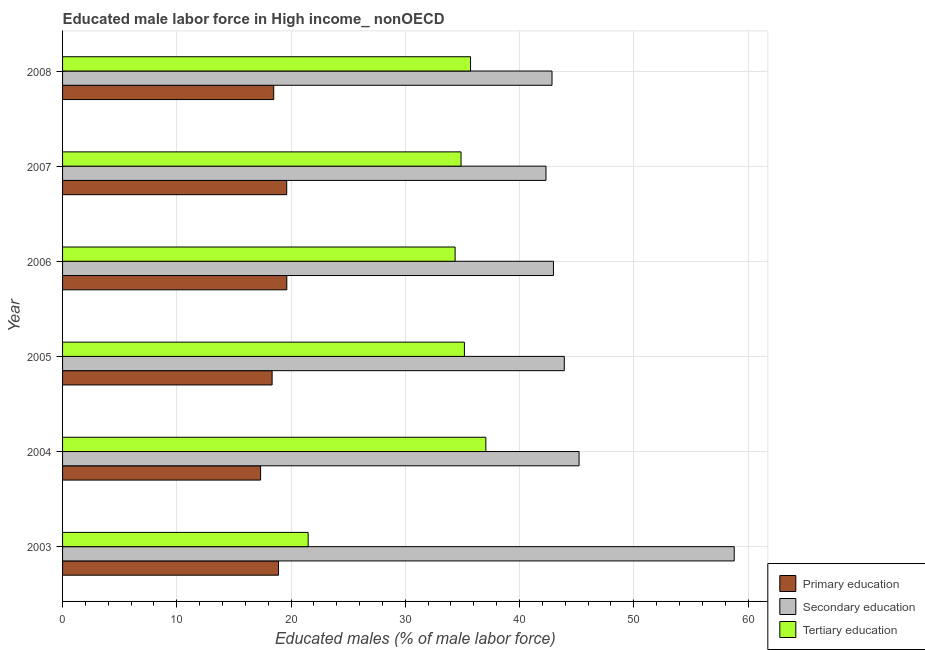How many different coloured bars are there?
Give a very brief answer. 3. How many groups of bars are there?
Make the answer very short. 6. Are the number of bars per tick equal to the number of legend labels?
Your response must be concise. Yes. Are the number of bars on each tick of the Y-axis equal?
Provide a short and direct response. Yes. How many bars are there on the 2nd tick from the top?
Your answer should be very brief. 3. How many bars are there on the 1st tick from the bottom?
Offer a terse response. 3. What is the percentage of male labor force who received secondary education in 2005?
Ensure brevity in your answer.  43.92. Across all years, what is the maximum percentage of male labor force who received tertiary education?
Your answer should be very brief. 37.05. Across all years, what is the minimum percentage of male labor force who received primary education?
Ensure brevity in your answer.  17.34. What is the total percentage of male labor force who received tertiary education in the graph?
Your response must be concise. 198.68. What is the difference between the percentage of male labor force who received tertiary education in 2004 and that in 2008?
Your answer should be compact. 1.34. What is the difference between the percentage of male labor force who received tertiary education in 2003 and the percentage of male labor force who received primary education in 2005?
Your answer should be compact. 3.16. What is the average percentage of male labor force who received secondary education per year?
Keep it short and to the point. 46.01. In the year 2005, what is the difference between the percentage of male labor force who received secondary education and percentage of male labor force who received primary education?
Provide a short and direct response. 25.58. In how many years, is the percentage of male labor force who received primary education greater than 24 %?
Keep it short and to the point. 0. What is the ratio of the percentage of male labor force who received primary education in 2005 to that in 2006?
Your answer should be very brief. 0.93. Is the percentage of male labor force who received tertiary education in 2003 less than that in 2004?
Your response must be concise. Yes. Is the difference between the percentage of male labor force who received tertiary education in 2004 and 2006 greater than the difference between the percentage of male labor force who received primary education in 2004 and 2006?
Provide a succinct answer. Yes. What is the difference between the highest and the second highest percentage of male labor force who received tertiary education?
Your response must be concise. 1.34. In how many years, is the percentage of male labor force who received secondary education greater than the average percentage of male labor force who received secondary education taken over all years?
Your response must be concise. 1. What does the 2nd bar from the top in 2006 represents?
Your response must be concise. Secondary education. What does the 3rd bar from the bottom in 2006 represents?
Make the answer very short. Tertiary education. How many bars are there?
Offer a very short reply. 18. Are all the bars in the graph horizontal?
Your answer should be very brief. Yes. How many years are there in the graph?
Ensure brevity in your answer.  6. Does the graph contain any zero values?
Provide a succinct answer. No. Where does the legend appear in the graph?
Your answer should be very brief. Bottom right. How are the legend labels stacked?
Your answer should be compact. Vertical. What is the title of the graph?
Provide a short and direct response. Educated male labor force in High income_ nonOECD. Does "Agriculture" appear as one of the legend labels in the graph?
Ensure brevity in your answer.  No. What is the label or title of the X-axis?
Offer a very short reply. Educated males (% of male labor force). What is the label or title of the Y-axis?
Your answer should be compact. Year. What is the Educated males (% of male labor force) of Primary education in 2003?
Keep it short and to the point. 18.9. What is the Educated males (% of male labor force) of Secondary education in 2003?
Ensure brevity in your answer.  58.79. What is the Educated males (% of male labor force) in Tertiary education in 2003?
Your answer should be very brief. 21.5. What is the Educated males (% of male labor force) in Primary education in 2004?
Your response must be concise. 17.34. What is the Educated males (% of male labor force) in Secondary education in 2004?
Keep it short and to the point. 45.21. What is the Educated males (% of male labor force) of Tertiary education in 2004?
Provide a short and direct response. 37.05. What is the Educated males (% of male labor force) of Primary education in 2005?
Your response must be concise. 18.34. What is the Educated males (% of male labor force) in Secondary education in 2005?
Give a very brief answer. 43.92. What is the Educated males (% of male labor force) of Tertiary education in 2005?
Keep it short and to the point. 35.18. What is the Educated males (% of male labor force) in Primary education in 2006?
Give a very brief answer. 19.63. What is the Educated males (% of male labor force) in Secondary education in 2006?
Make the answer very short. 42.97. What is the Educated males (% of male labor force) of Tertiary education in 2006?
Keep it short and to the point. 34.36. What is the Educated males (% of male labor force) in Primary education in 2007?
Keep it short and to the point. 19.62. What is the Educated males (% of male labor force) in Secondary education in 2007?
Give a very brief answer. 42.32. What is the Educated males (% of male labor force) in Tertiary education in 2007?
Your answer should be very brief. 34.88. What is the Educated males (% of male labor force) in Primary education in 2008?
Provide a succinct answer. 18.48. What is the Educated males (% of male labor force) of Secondary education in 2008?
Give a very brief answer. 42.84. What is the Educated males (% of male labor force) of Tertiary education in 2008?
Give a very brief answer. 35.71. Across all years, what is the maximum Educated males (% of male labor force) in Primary education?
Make the answer very short. 19.63. Across all years, what is the maximum Educated males (% of male labor force) of Secondary education?
Provide a short and direct response. 58.79. Across all years, what is the maximum Educated males (% of male labor force) in Tertiary education?
Provide a short and direct response. 37.05. Across all years, what is the minimum Educated males (% of male labor force) in Primary education?
Offer a terse response. 17.34. Across all years, what is the minimum Educated males (% of male labor force) of Secondary education?
Your answer should be very brief. 42.32. Across all years, what is the minimum Educated males (% of male labor force) in Tertiary education?
Offer a terse response. 21.5. What is the total Educated males (% of male labor force) of Primary education in the graph?
Offer a very short reply. 112.32. What is the total Educated males (% of male labor force) of Secondary education in the graph?
Provide a succinct answer. 276.06. What is the total Educated males (% of male labor force) of Tertiary education in the graph?
Your answer should be very brief. 198.68. What is the difference between the Educated males (% of male labor force) of Primary education in 2003 and that in 2004?
Offer a very short reply. 1.57. What is the difference between the Educated males (% of male labor force) in Secondary education in 2003 and that in 2004?
Provide a short and direct response. 13.58. What is the difference between the Educated males (% of male labor force) of Tertiary education in 2003 and that in 2004?
Your answer should be very brief. -15.55. What is the difference between the Educated males (% of male labor force) in Primary education in 2003 and that in 2005?
Your answer should be compact. 0.56. What is the difference between the Educated males (% of male labor force) of Secondary education in 2003 and that in 2005?
Your response must be concise. 14.87. What is the difference between the Educated males (% of male labor force) of Tertiary education in 2003 and that in 2005?
Offer a terse response. -13.68. What is the difference between the Educated males (% of male labor force) of Primary education in 2003 and that in 2006?
Provide a succinct answer. -0.73. What is the difference between the Educated males (% of male labor force) in Secondary education in 2003 and that in 2006?
Keep it short and to the point. 15.82. What is the difference between the Educated males (% of male labor force) in Tertiary education in 2003 and that in 2006?
Give a very brief answer. -12.86. What is the difference between the Educated males (% of male labor force) in Primary education in 2003 and that in 2007?
Provide a short and direct response. -0.72. What is the difference between the Educated males (% of male labor force) of Secondary education in 2003 and that in 2007?
Your answer should be compact. 16.48. What is the difference between the Educated males (% of male labor force) of Tertiary education in 2003 and that in 2007?
Your answer should be compact. -13.38. What is the difference between the Educated males (% of male labor force) of Primary education in 2003 and that in 2008?
Provide a short and direct response. 0.42. What is the difference between the Educated males (% of male labor force) of Secondary education in 2003 and that in 2008?
Your answer should be very brief. 15.95. What is the difference between the Educated males (% of male labor force) in Tertiary education in 2003 and that in 2008?
Your response must be concise. -14.21. What is the difference between the Educated males (% of male labor force) in Primary education in 2004 and that in 2005?
Keep it short and to the point. -1.01. What is the difference between the Educated males (% of male labor force) in Secondary education in 2004 and that in 2005?
Offer a very short reply. 1.29. What is the difference between the Educated males (% of male labor force) in Tertiary education in 2004 and that in 2005?
Make the answer very short. 1.88. What is the difference between the Educated males (% of male labor force) of Primary education in 2004 and that in 2006?
Offer a terse response. -2.3. What is the difference between the Educated males (% of male labor force) in Secondary education in 2004 and that in 2006?
Make the answer very short. 2.24. What is the difference between the Educated males (% of male labor force) in Tertiary education in 2004 and that in 2006?
Make the answer very short. 2.69. What is the difference between the Educated males (% of male labor force) in Primary education in 2004 and that in 2007?
Your response must be concise. -2.29. What is the difference between the Educated males (% of male labor force) of Secondary education in 2004 and that in 2007?
Provide a succinct answer. 2.9. What is the difference between the Educated males (% of male labor force) of Tertiary education in 2004 and that in 2007?
Offer a terse response. 2.17. What is the difference between the Educated males (% of male labor force) of Primary education in 2004 and that in 2008?
Keep it short and to the point. -1.15. What is the difference between the Educated males (% of male labor force) in Secondary education in 2004 and that in 2008?
Provide a succinct answer. 2.37. What is the difference between the Educated males (% of male labor force) of Tertiary education in 2004 and that in 2008?
Give a very brief answer. 1.34. What is the difference between the Educated males (% of male labor force) in Primary education in 2005 and that in 2006?
Provide a succinct answer. -1.29. What is the difference between the Educated males (% of male labor force) in Secondary education in 2005 and that in 2006?
Your answer should be compact. 0.95. What is the difference between the Educated males (% of male labor force) in Tertiary education in 2005 and that in 2006?
Make the answer very short. 0.81. What is the difference between the Educated males (% of male labor force) in Primary education in 2005 and that in 2007?
Provide a succinct answer. -1.28. What is the difference between the Educated males (% of male labor force) in Secondary education in 2005 and that in 2007?
Offer a terse response. 1.6. What is the difference between the Educated males (% of male labor force) in Tertiary education in 2005 and that in 2007?
Make the answer very short. 0.3. What is the difference between the Educated males (% of male labor force) in Primary education in 2005 and that in 2008?
Your answer should be compact. -0.14. What is the difference between the Educated males (% of male labor force) in Secondary education in 2005 and that in 2008?
Make the answer very short. 1.08. What is the difference between the Educated males (% of male labor force) in Tertiary education in 2005 and that in 2008?
Offer a terse response. -0.54. What is the difference between the Educated males (% of male labor force) of Primary education in 2006 and that in 2007?
Offer a very short reply. 0.01. What is the difference between the Educated males (% of male labor force) of Secondary education in 2006 and that in 2007?
Your response must be concise. 0.65. What is the difference between the Educated males (% of male labor force) of Tertiary education in 2006 and that in 2007?
Provide a short and direct response. -0.52. What is the difference between the Educated males (% of male labor force) of Primary education in 2006 and that in 2008?
Give a very brief answer. 1.15. What is the difference between the Educated males (% of male labor force) of Secondary education in 2006 and that in 2008?
Make the answer very short. 0.13. What is the difference between the Educated males (% of male labor force) in Tertiary education in 2006 and that in 2008?
Provide a short and direct response. -1.35. What is the difference between the Educated males (% of male labor force) in Primary education in 2007 and that in 2008?
Offer a terse response. 1.14. What is the difference between the Educated males (% of male labor force) of Secondary education in 2007 and that in 2008?
Your answer should be very brief. -0.53. What is the difference between the Educated males (% of male labor force) of Tertiary education in 2007 and that in 2008?
Make the answer very short. -0.83. What is the difference between the Educated males (% of male labor force) of Primary education in 2003 and the Educated males (% of male labor force) of Secondary education in 2004?
Provide a succinct answer. -26.31. What is the difference between the Educated males (% of male labor force) in Primary education in 2003 and the Educated males (% of male labor force) in Tertiary education in 2004?
Provide a short and direct response. -18.15. What is the difference between the Educated males (% of male labor force) in Secondary education in 2003 and the Educated males (% of male labor force) in Tertiary education in 2004?
Offer a terse response. 21.74. What is the difference between the Educated males (% of male labor force) in Primary education in 2003 and the Educated males (% of male labor force) in Secondary education in 2005?
Your response must be concise. -25.02. What is the difference between the Educated males (% of male labor force) in Primary education in 2003 and the Educated males (% of male labor force) in Tertiary education in 2005?
Provide a succinct answer. -16.27. What is the difference between the Educated males (% of male labor force) in Secondary education in 2003 and the Educated males (% of male labor force) in Tertiary education in 2005?
Your answer should be compact. 23.62. What is the difference between the Educated males (% of male labor force) of Primary education in 2003 and the Educated males (% of male labor force) of Secondary education in 2006?
Your response must be concise. -24.07. What is the difference between the Educated males (% of male labor force) in Primary education in 2003 and the Educated males (% of male labor force) in Tertiary education in 2006?
Provide a succinct answer. -15.46. What is the difference between the Educated males (% of male labor force) of Secondary education in 2003 and the Educated males (% of male labor force) of Tertiary education in 2006?
Keep it short and to the point. 24.43. What is the difference between the Educated males (% of male labor force) of Primary education in 2003 and the Educated males (% of male labor force) of Secondary education in 2007?
Provide a short and direct response. -23.41. What is the difference between the Educated males (% of male labor force) of Primary education in 2003 and the Educated males (% of male labor force) of Tertiary education in 2007?
Make the answer very short. -15.98. What is the difference between the Educated males (% of male labor force) of Secondary education in 2003 and the Educated males (% of male labor force) of Tertiary education in 2007?
Give a very brief answer. 23.91. What is the difference between the Educated males (% of male labor force) of Primary education in 2003 and the Educated males (% of male labor force) of Secondary education in 2008?
Your answer should be very brief. -23.94. What is the difference between the Educated males (% of male labor force) in Primary education in 2003 and the Educated males (% of male labor force) in Tertiary education in 2008?
Provide a succinct answer. -16.81. What is the difference between the Educated males (% of male labor force) of Secondary education in 2003 and the Educated males (% of male labor force) of Tertiary education in 2008?
Offer a very short reply. 23.08. What is the difference between the Educated males (% of male labor force) in Primary education in 2004 and the Educated males (% of male labor force) in Secondary education in 2005?
Offer a very short reply. -26.58. What is the difference between the Educated males (% of male labor force) in Primary education in 2004 and the Educated males (% of male labor force) in Tertiary education in 2005?
Keep it short and to the point. -17.84. What is the difference between the Educated males (% of male labor force) of Secondary education in 2004 and the Educated males (% of male labor force) of Tertiary education in 2005?
Your answer should be very brief. 10.04. What is the difference between the Educated males (% of male labor force) in Primary education in 2004 and the Educated males (% of male labor force) in Secondary education in 2006?
Your response must be concise. -25.64. What is the difference between the Educated males (% of male labor force) in Primary education in 2004 and the Educated males (% of male labor force) in Tertiary education in 2006?
Your answer should be very brief. -17.03. What is the difference between the Educated males (% of male labor force) in Secondary education in 2004 and the Educated males (% of male labor force) in Tertiary education in 2006?
Your response must be concise. 10.85. What is the difference between the Educated males (% of male labor force) of Primary education in 2004 and the Educated males (% of male labor force) of Secondary education in 2007?
Give a very brief answer. -24.98. What is the difference between the Educated males (% of male labor force) of Primary education in 2004 and the Educated males (% of male labor force) of Tertiary education in 2007?
Your answer should be compact. -17.55. What is the difference between the Educated males (% of male labor force) in Secondary education in 2004 and the Educated males (% of male labor force) in Tertiary education in 2007?
Provide a succinct answer. 10.33. What is the difference between the Educated males (% of male labor force) of Primary education in 2004 and the Educated males (% of male labor force) of Secondary education in 2008?
Your answer should be very brief. -25.51. What is the difference between the Educated males (% of male labor force) of Primary education in 2004 and the Educated males (% of male labor force) of Tertiary education in 2008?
Make the answer very short. -18.38. What is the difference between the Educated males (% of male labor force) in Secondary education in 2004 and the Educated males (% of male labor force) in Tertiary education in 2008?
Make the answer very short. 9.5. What is the difference between the Educated males (% of male labor force) in Primary education in 2005 and the Educated males (% of male labor force) in Secondary education in 2006?
Offer a very short reply. -24.63. What is the difference between the Educated males (% of male labor force) of Primary education in 2005 and the Educated males (% of male labor force) of Tertiary education in 2006?
Keep it short and to the point. -16.02. What is the difference between the Educated males (% of male labor force) of Secondary education in 2005 and the Educated males (% of male labor force) of Tertiary education in 2006?
Give a very brief answer. 9.56. What is the difference between the Educated males (% of male labor force) in Primary education in 2005 and the Educated males (% of male labor force) in Secondary education in 2007?
Ensure brevity in your answer.  -23.97. What is the difference between the Educated males (% of male labor force) of Primary education in 2005 and the Educated males (% of male labor force) of Tertiary education in 2007?
Offer a very short reply. -16.54. What is the difference between the Educated males (% of male labor force) in Secondary education in 2005 and the Educated males (% of male labor force) in Tertiary education in 2007?
Provide a short and direct response. 9.04. What is the difference between the Educated males (% of male labor force) in Primary education in 2005 and the Educated males (% of male labor force) in Secondary education in 2008?
Make the answer very short. -24.5. What is the difference between the Educated males (% of male labor force) of Primary education in 2005 and the Educated males (% of male labor force) of Tertiary education in 2008?
Give a very brief answer. -17.37. What is the difference between the Educated males (% of male labor force) of Secondary education in 2005 and the Educated males (% of male labor force) of Tertiary education in 2008?
Your answer should be very brief. 8.21. What is the difference between the Educated males (% of male labor force) in Primary education in 2006 and the Educated males (% of male labor force) in Secondary education in 2007?
Your response must be concise. -22.69. What is the difference between the Educated males (% of male labor force) of Primary education in 2006 and the Educated males (% of male labor force) of Tertiary education in 2007?
Make the answer very short. -15.25. What is the difference between the Educated males (% of male labor force) in Secondary education in 2006 and the Educated males (% of male labor force) in Tertiary education in 2007?
Keep it short and to the point. 8.09. What is the difference between the Educated males (% of male labor force) in Primary education in 2006 and the Educated males (% of male labor force) in Secondary education in 2008?
Give a very brief answer. -23.21. What is the difference between the Educated males (% of male labor force) in Primary education in 2006 and the Educated males (% of male labor force) in Tertiary education in 2008?
Give a very brief answer. -16.08. What is the difference between the Educated males (% of male labor force) of Secondary education in 2006 and the Educated males (% of male labor force) of Tertiary education in 2008?
Your answer should be very brief. 7.26. What is the difference between the Educated males (% of male labor force) in Primary education in 2007 and the Educated males (% of male labor force) in Secondary education in 2008?
Your answer should be compact. -23.22. What is the difference between the Educated males (% of male labor force) of Primary education in 2007 and the Educated males (% of male labor force) of Tertiary education in 2008?
Offer a very short reply. -16.09. What is the difference between the Educated males (% of male labor force) in Secondary education in 2007 and the Educated males (% of male labor force) in Tertiary education in 2008?
Your response must be concise. 6.61. What is the average Educated males (% of male labor force) of Primary education per year?
Provide a succinct answer. 18.72. What is the average Educated males (% of male labor force) of Secondary education per year?
Your response must be concise. 46.01. What is the average Educated males (% of male labor force) in Tertiary education per year?
Offer a very short reply. 33.11. In the year 2003, what is the difference between the Educated males (% of male labor force) of Primary education and Educated males (% of male labor force) of Secondary education?
Your answer should be very brief. -39.89. In the year 2003, what is the difference between the Educated males (% of male labor force) in Primary education and Educated males (% of male labor force) in Tertiary education?
Give a very brief answer. -2.6. In the year 2003, what is the difference between the Educated males (% of male labor force) of Secondary education and Educated males (% of male labor force) of Tertiary education?
Your response must be concise. 37.3. In the year 2004, what is the difference between the Educated males (% of male labor force) in Primary education and Educated males (% of male labor force) in Secondary education?
Provide a succinct answer. -27.88. In the year 2004, what is the difference between the Educated males (% of male labor force) in Primary education and Educated males (% of male labor force) in Tertiary education?
Give a very brief answer. -19.72. In the year 2004, what is the difference between the Educated males (% of male labor force) in Secondary education and Educated males (% of male labor force) in Tertiary education?
Your response must be concise. 8.16. In the year 2005, what is the difference between the Educated males (% of male labor force) in Primary education and Educated males (% of male labor force) in Secondary education?
Your response must be concise. -25.58. In the year 2005, what is the difference between the Educated males (% of male labor force) of Primary education and Educated males (% of male labor force) of Tertiary education?
Your answer should be compact. -16.83. In the year 2005, what is the difference between the Educated males (% of male labor force) in Secondary education and Educated males (% of male labor force) in Tertiary education?
Offer a terse response. 8.74. In the year 2006, what is the difference between the Educated males (% of male labor force) of Primary education and Educated males (% of male labor force) of Secondary education?
Ensure brevity in your answer.  -23.34. In the year 2006, what is the difference between the Educated males (% of male labor force) in Primary education and Educated males (% of male labor force) in Tertiary education?
Your answer should be compact. -14.73. In the year 2006, what is the difference between the Educated males (% of male labor force) in Secondary education and Educated males (% of male labor force) in Tertiary education?
Offer a very short reply. 8.61. In the year 2007, what is the difference between the Educated males (% of male labor force) in Primary education and Educated males (% of male labor force) in Secondary education?
Keep it short and to the point. -22.7. In the year 2007, what is the difference between the Educated males (% of male labor force) of Primary education and Educated males (% of male labor force) of Tertiary education?
Offer a terse response. -15.26. In the year 2007, what is the difference between the Educated males (% of male labor force) of Secondary education and Educated males (% of male labor force) of Tertiary education?
Provide a short and direct response. 7.44. In the year 2008, what is the difference between the Educated males (% of male labor force) in Primary education and Educated males (% of male labor force) in Secondary education?
Offer a very short reply. -24.36. In the year 2008, what is the difference between the Educated males (% of male labor force) in Primary education and Educated males (% of male labor force) in Tertiary education?
Offer a terse response. -17.23. In the year 2008, what is the difference between the Educated males (% of male labor force) in Secondary education and Educated males (% of male labor force) in Tertiary education?
Give a very brief answer. 7.13. What is the ratio of the Educated males (% of male labor force) in Primary education in 2003 to that in 2004?
Give a very brief answer. 1.09. What is the ratio of the Educated males (% of male labor force) in Secondary education in 2003 to that in 2004?
Your answer should be very brief. 1.3. What is the ratio of the Educated males (% of male labor force) of Tertiary education in 2003 to that in 2004?
Offer a terse response. 0.58. What is the ratio of the Educated males (% of male labor force) in Primary education in 2003 to that in 2005?
Keep it short and to the point. 1.03. What is the ratio of the Educated males (% of male labor force) of Secondary education in 2003 to that in 2005?
Ensure brevity in your answer.  1.34. What is the ratio of the Educated males (% of male labor force) of Tertiary education in 2003 to that in 2005?
Make the answer very short. 0.61. What is the ratio of the Educated males (% of male labor force) of Primary education in 2003 to that in 2006?
Offer a very short reply. 0.96. What is the ratio of the Educated males (% of male labor force) in Secondary education in 2003 to that in 2006?
Your response must be concise. 1.37. What is the ratio of the Educated males (% of male labor force) of Tertiary education in 2003 to that in 2006?
Ensure brevity in your answer.  0.63. What is the ratio of the Educated males (% of male labor force) of Primary education in 2003 to that in 2007?
Give a very brief answer. 0.96. What is the ratio of the Educated males (% of male labor force) of Secondary education in 2003 to that in 2007?
Ensure brevity in your answer.  1.39. What is the ratio of the Educated males (% of male labor force) in Tertiary education in 2003 to that in 2007?
Make the answer very short. 0.62. What is the ratio of the Educated males (% of male labor force) of Primary education in 2003 to that in 2008?
Ensure brevity in your answer.  1.02. What is the ratio of the Educated males (% of male labor force) in Secondary education in 2003 to that in 2008?
Offer a terse response. 1.37. What is the ratio of the Educated males (% of male labor force) of Tertiary education in 2003 to that in 2008?
Offer a very short reply. 0.6. What is the ratio of the Educated males (% of male labor force) in Primary education in 2004 to that in 2005?
Keep it short and to the point. 0.94. What is the ratio of the Educated males (% of male labor force) in Secondary education in 2004 to that in 2005?
Your answer should be compact. 1.03. What is the ratio of the Educated males (% of male labor force) in Tertiary education in 2004 to that in 2005?
Keep it short and to the point. 1.05. What is the ratio of the Educated males (% of male labor force) in Primary education in 2004 to that in 2006?
Make the answer very short. 0.88. What is the ratio of the Educated males (% of male labor force) in Secondary education in 2004 to that in 2006?
Offer a terse response. 1.05. What is the ratio of the Educated males (% of male labor force) of Tertiary education in 2004 to that in 2006?
Provide a short and direct response. 1.08. What is the ratio of the Educated males (% of male labor force) of Primary education in 2004 to that in 2007?
Make the answer very short. 0.88. What is the ratio of the Educated males (% of male labor force) of Secondary education in 2004 to that in 2007?
Provide a succinct answer. 1.07. What is the ratio of the Educated males (% of male labor force) in Tertiary education in 2004 to that in 2007?
Your answer should be compact. 1.06. What is the ratio of the Educated males (% of male labor force) in Primary education in 2004 to that in 2008?
Keep it short and to the point. 0.94. What is the ratio of the Educated males (% of male labor force) in Secondary education in 2004 to that in 2008?
Ensure brevity in your answer.  1.06. What is the ratio of the Educated males (% of male labor force) in Tertiary education in 2004 to that in 2008?
Your response must be concise. 1.04. What is the ratio of the Educated males (% of male labor force) of Primary education in 2005 to that in 2006?
Keep it short and to the point. 0.93. What is the ratio of the Educated males (% of male labor force) in Secondary education in 2005 to that in 2006?
Your answer should be very brief. 1.02. What is the ratio of the Educated males (% of male labor force) in Tertiary education in 2005 to that in 2006?
Provide a short and direct response. 1.02. What is the ratio of the Educated males (% of male labor force) in Primary education in 2005 to that in 2007?
Your answer should be compact. 0.93. What is the ratio of the Educated males (% of male labor force) in Secondary education in 2005 to that in 2007?
Make the answer very short. 1.04. What is the ratio of the Educated males (% of male labor force) in Tertiary education in 2005 to that in 2007?
Your answer should be compact. 1.01. What is the ratio of the Educated males (% of male labor force) of Primary education in 2005 to that in 2008?
Offer a very short reply. 0.99. What is the ratio of the Educated males (% of male labor force) in Secondary education in 2005 to that in 2008?
Offer a very short reply. 1.03. What is the ratio of the Educated males (% of male labor force) of Primary education in 2006 to that in 2007?
Give a very brief answer. 1. What is the ratio of the Educated males (% of male labor force) in Secondary education in 2006 to that in 2007?
Your answer should be very brief. 1.02. What is the ratio of the Educated males (% of male labor force) of Tertiary education in 2006 to that in 2007?
Give a very brief answer. 0.99. What is the ratio of the Educated males (% of male labor force) of Primary education in 2006 to that in 2008?
Your answer should be very brief. 1.06. What is the ratio of the Educated males (% of male labor force) of Tertiary education in 2006 to that in 2008?
Offer a terse response. 0.96. What is the ratio of the Educated males (% of male labor force) of Primary education in 2007 to that in 2008?
Provide a short and direct response. 1.06. What is the ratio of the Educated males (% of male labor force) of Tertiary education in 2007 to that in 2008?
Provide a short and direct response. 0.98. What is the difference between the highest and the second highest Educated males (% of male labor force) of Primary education?
Your answer should be very brief. 0.01. What is the difference between the highest and the second highest Educated males (% of male labor force) in Secondary education?
Offer a very short reply. 13.58. What is the difference between the highest and the second highest Educated males (% of male labor force) of Tertiary education?
Provide a short and direct response. 1.34. What is the difference between the highest and the lowest Educated males (% of male labor force) of Primary education?
Ensure brevity in your answer.  2.3. What is the difference between the highest and the lowest Educated males (% of male labor force) in Secondary education?
Make the answer very short. 16.48. What is the difference between the highest and the lowest Educated males (% of male labor force) of Tertiary education?
Offer a terse response. 15.55. 